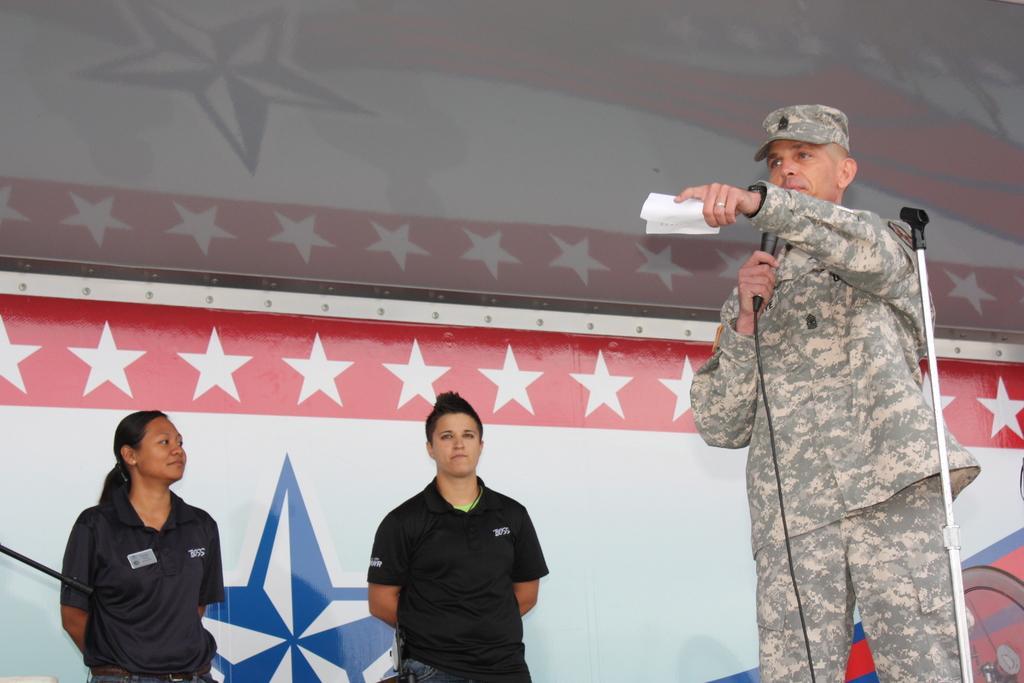In one or two sentences, can you explain what this image depicts? In this image I can see three persons standing. In front the person is holding the microphone and the person is wearing military dress, background I can see the board in white, blue and red color. 